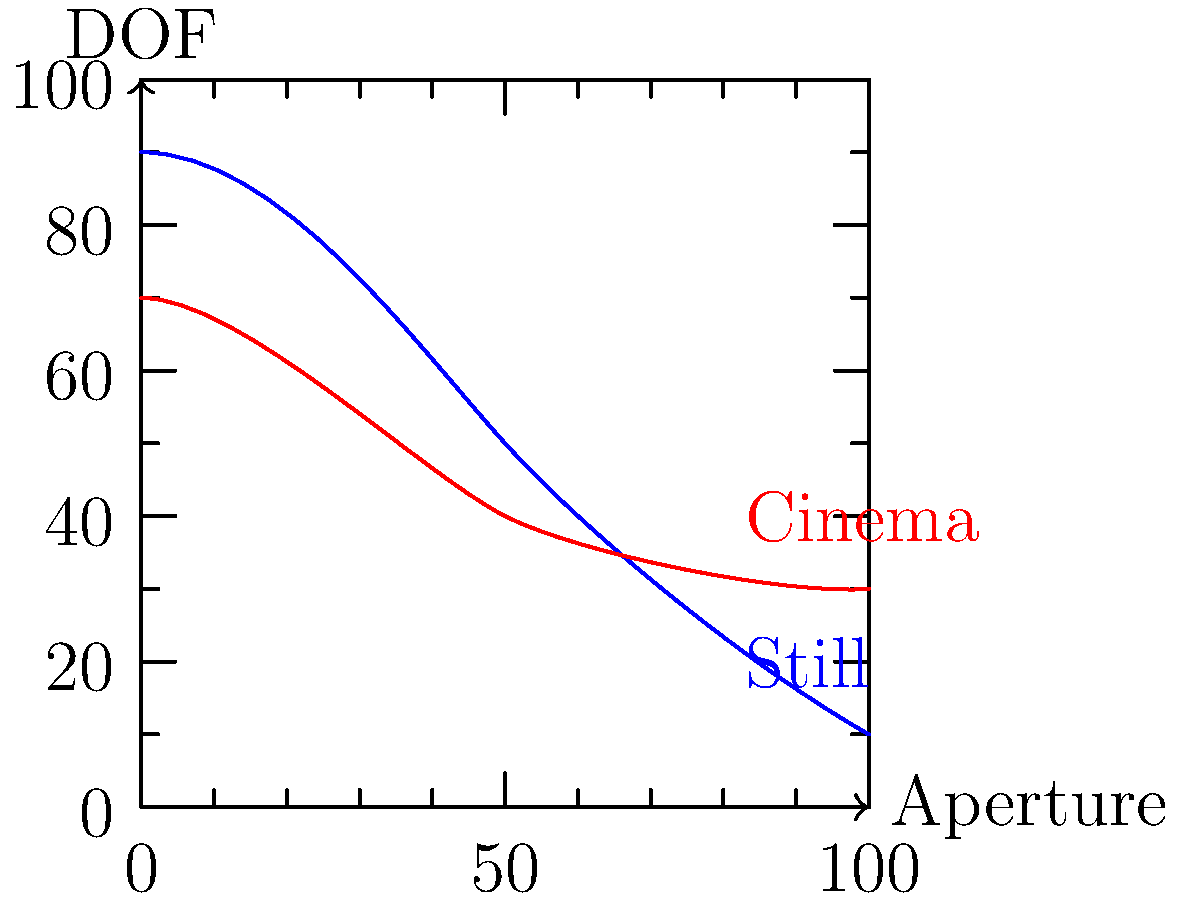Analyze the graph depicting the relationship between aperture and depth of field (DOF) for still photography and cinematography. Which technique generally allows for a shallower depth of field at the same aperture settings? To answer this question, let's analyze the graph step-by-step:

1. The x-axis represents the aperture, with smaller numbers (to the left) indicating wider apertures and larger numbers (to the right) indicating narrower apertures.

2. The y-axis represents the depth of field (DOF), with higher values indicating a larger DOF and lower values indicating a shallower DOF.

3. The blue curve represents still photography, while the red curve represents cinematography.

4. Observe that for any given point on the x-axis (aperture):
   a. The blue curve (still photography) is generally higher on the y-axis than the red curve (cinematography).
   b. This means that for the same aperture setting, still photography typically results in a larger depth of field.

5. Conversely, cinematography (red curve) shows a lower position on the y-axis for any given aperture, indicating a shallower depth of field.

6. The difference is more pronounced at wider apertures (left side of the graph) and becomes less significant at narrower apertures (right side of the graph).

This difference is often due to factors such as:
- Larger sensor sizes typically used in cinema cameras
- Different focal lengths commonly used in cinematography
- Motion blur in cinematography, which can affect perceived sharpness

Therefore, based on this graph, cinematography generally allows for a shallower depth of field at the same aperture settings compared to still photography.
Answer: Cinematography 